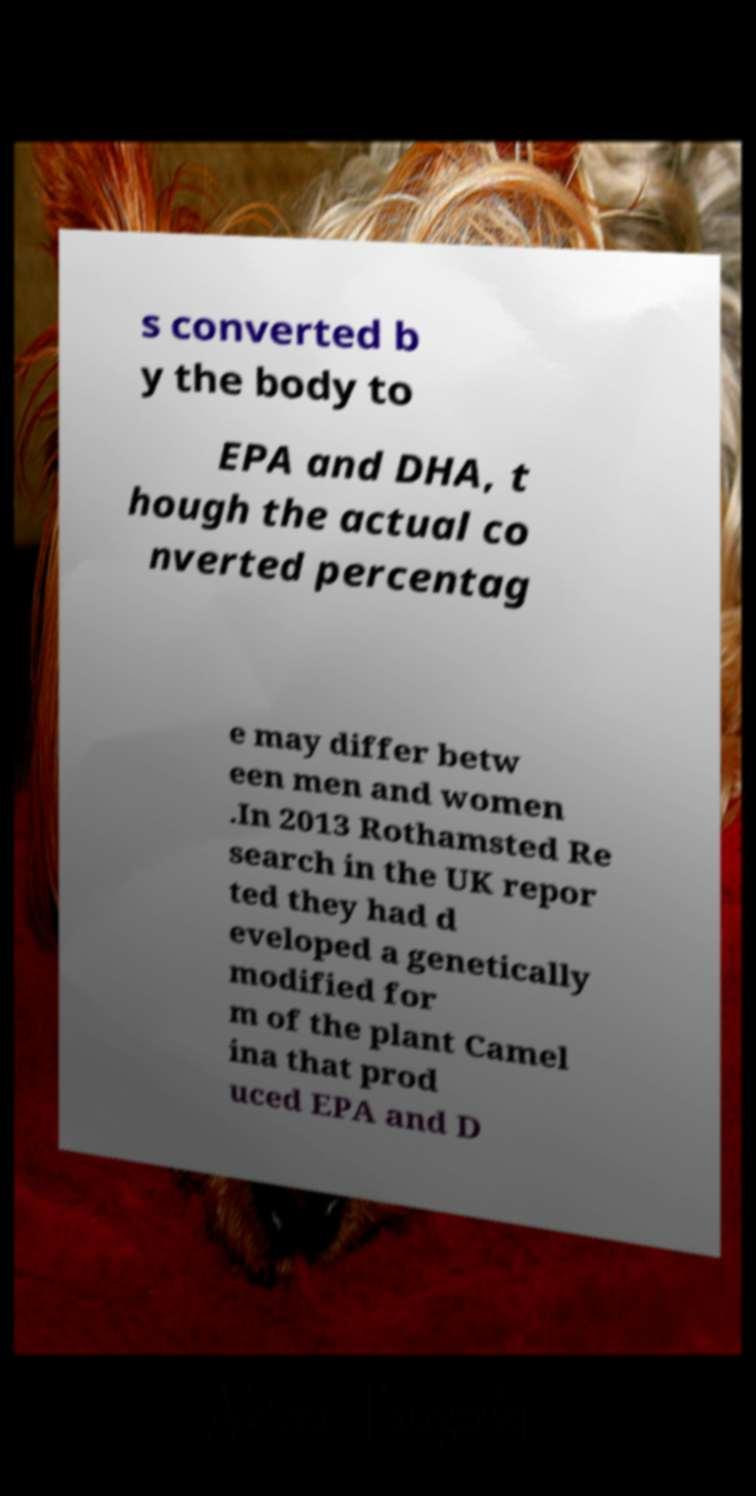Could you extract and type out the text from this image? s converted b y the body to EPA and DHA, t hough the actual co nverted percentag e may differ betw een men and women .In 2013 Rothamsted Re search in the UK repor ted they had d eveloped a genetically modified for m of the plant Camel ina that prod uced EPA and D 